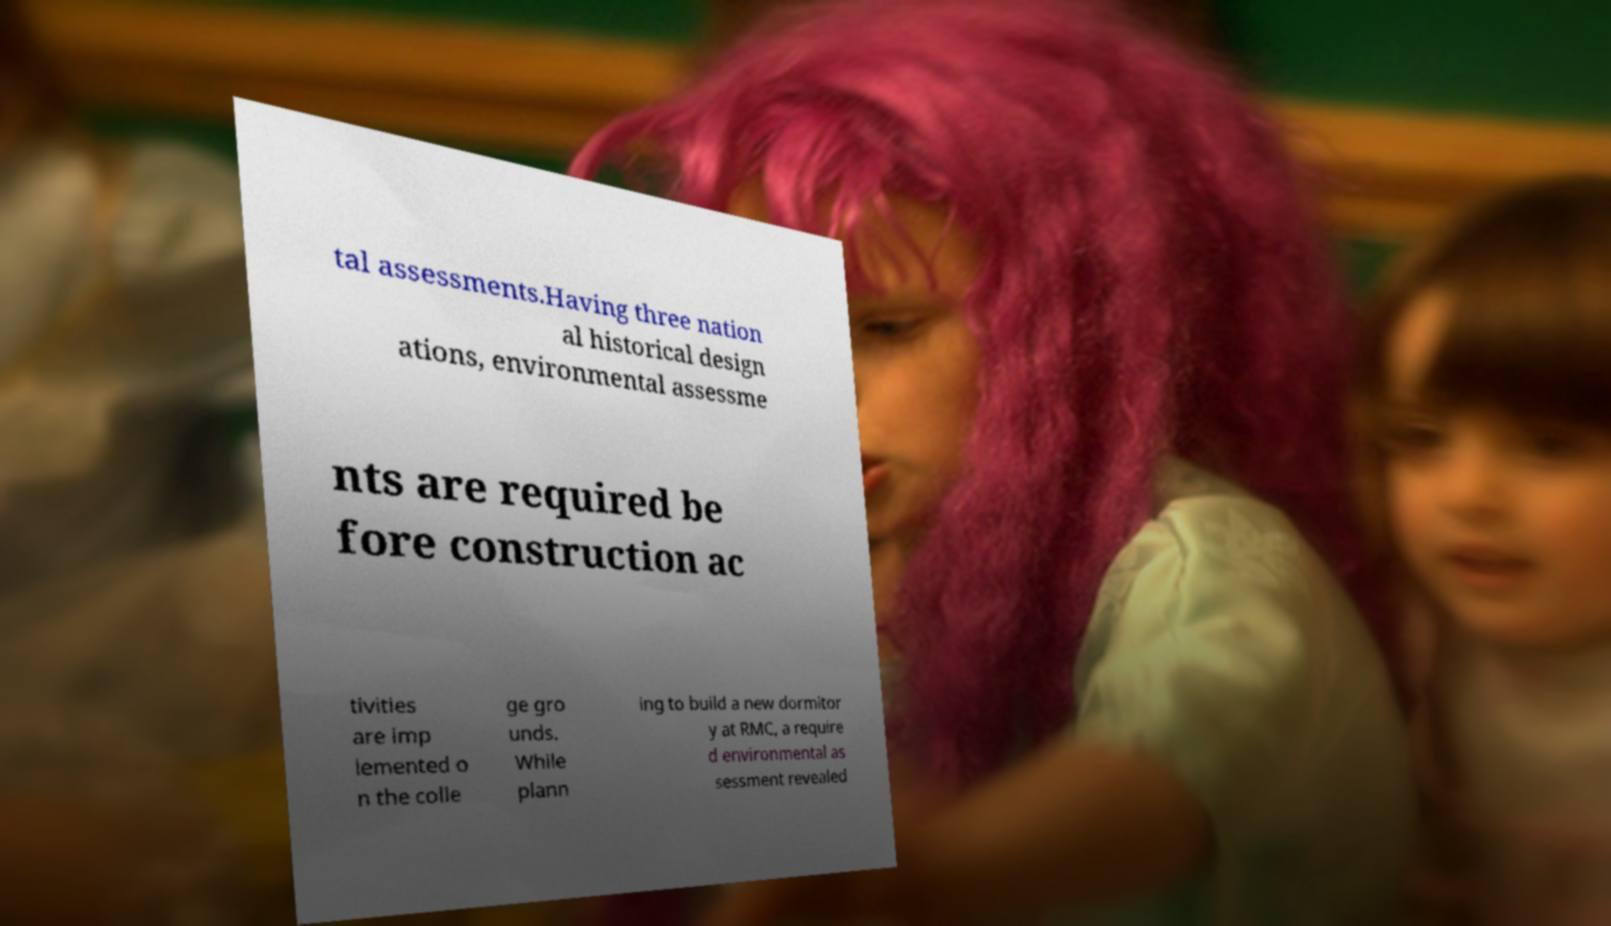Could you assist in decoding the text presented in this image and type it out clearly? tal assessments.Having three nation al historical design ations, environmental assessme nts are required be fore construction ac tivities are imp lemented o n the colle ge gro unds. While plann ing to build a new dormitor y at RMC, a require d environmental as sessment revealed 